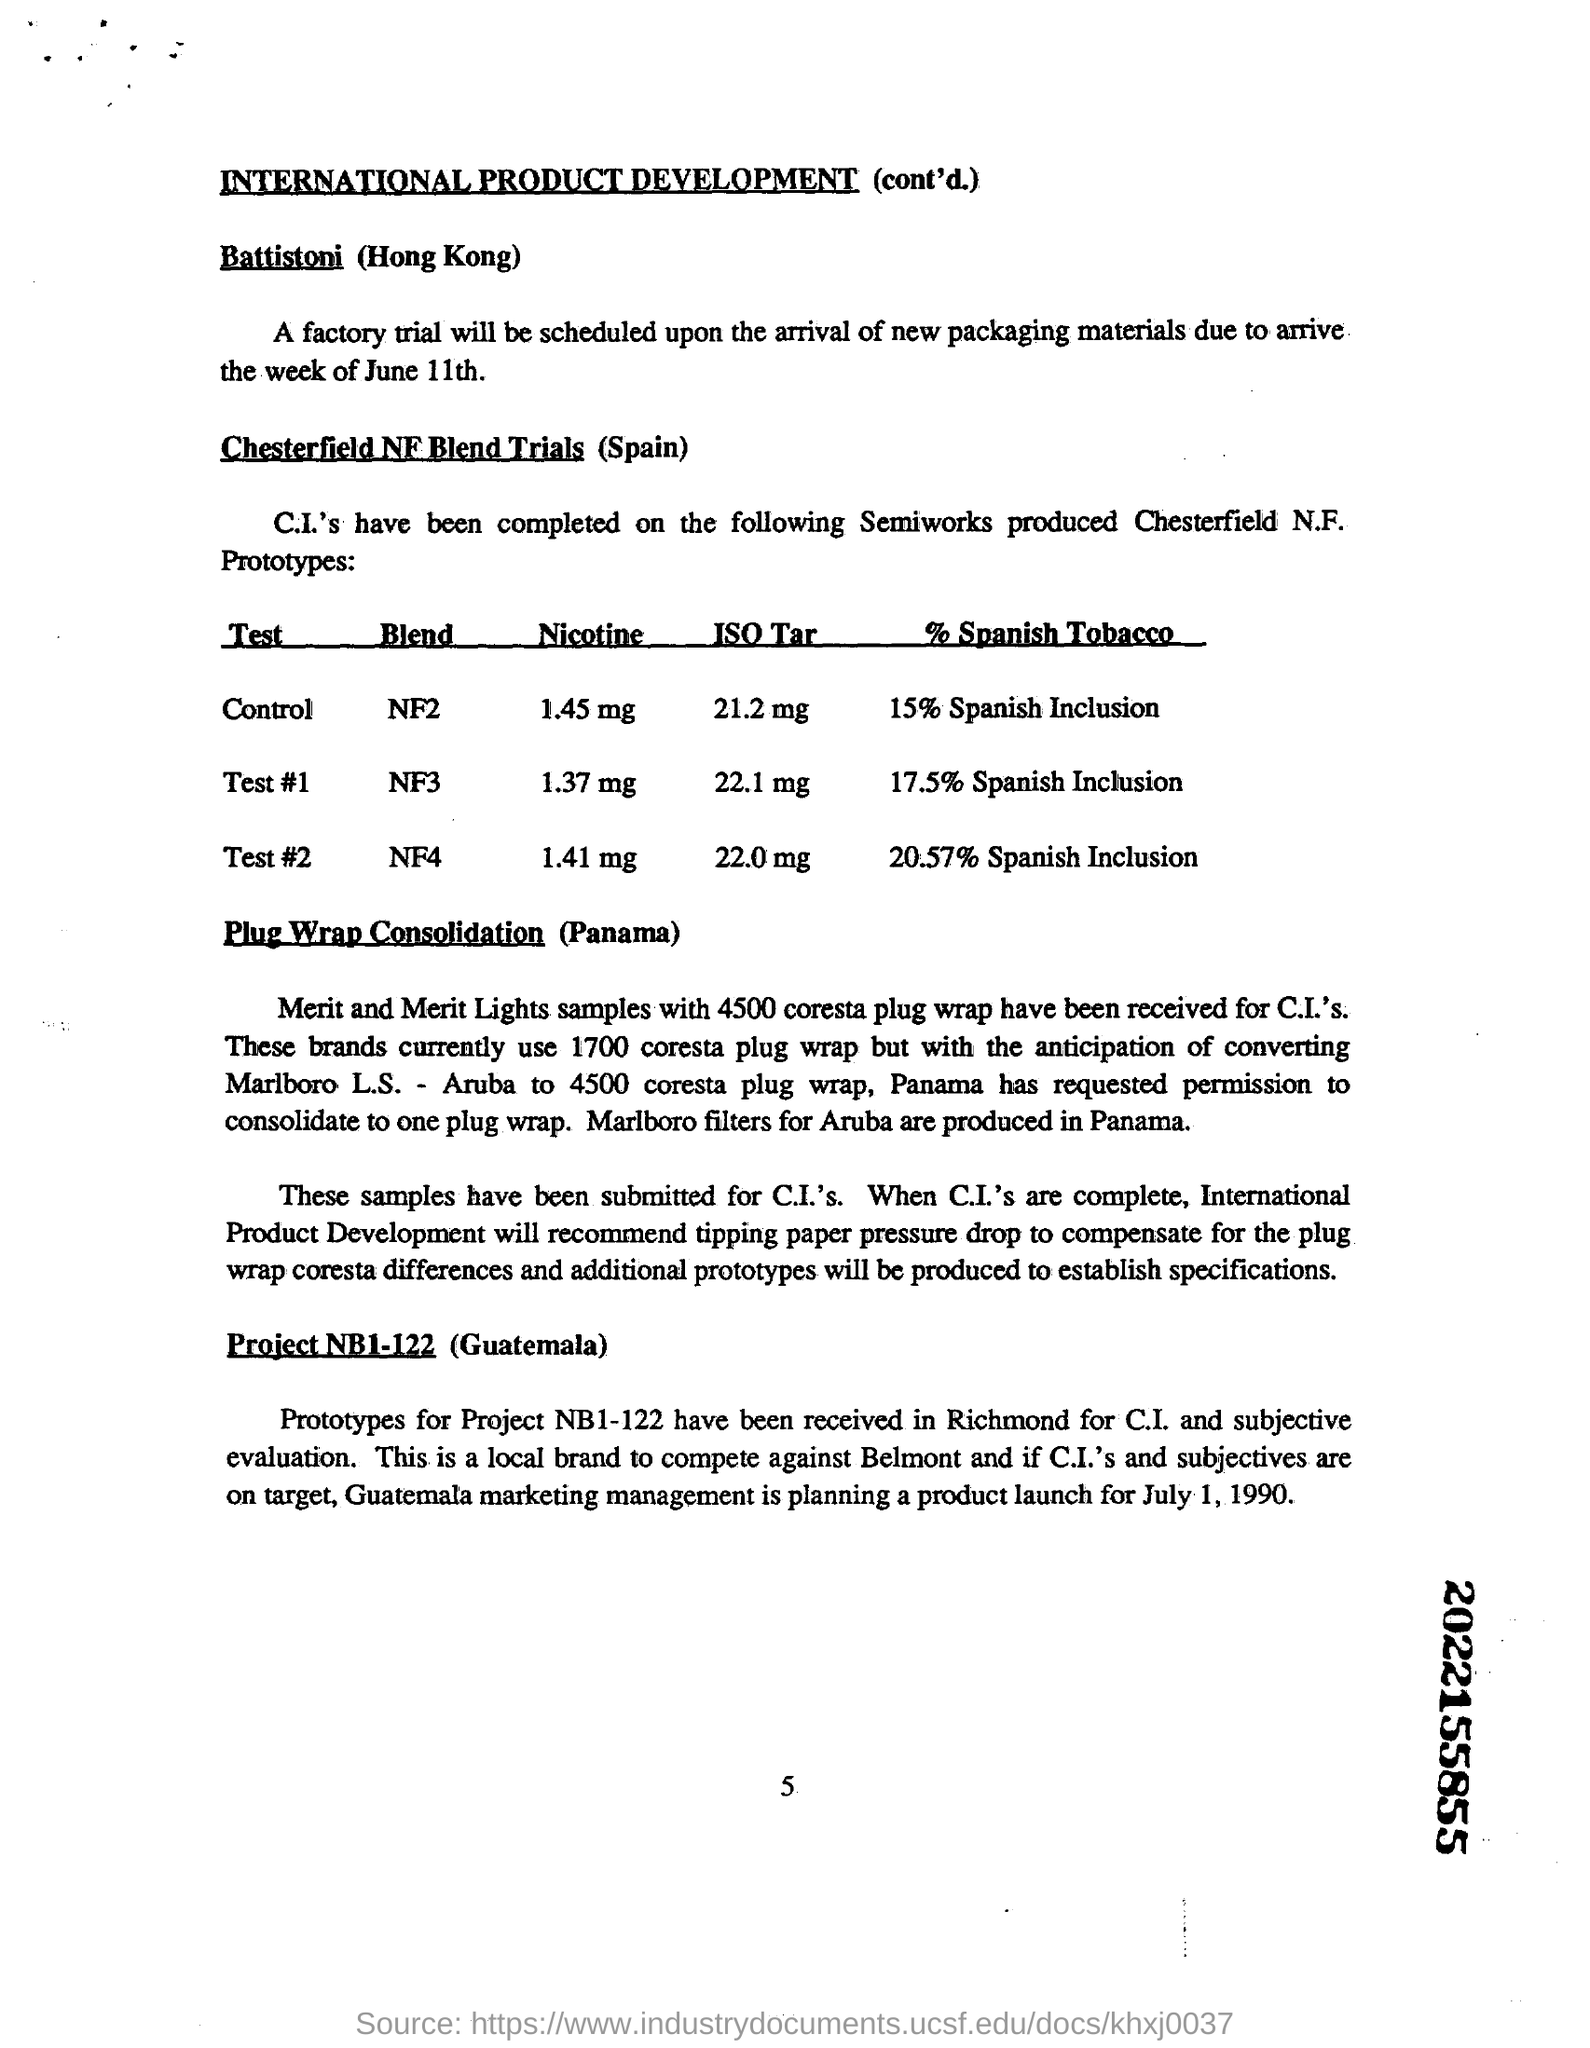How many % of Spanish Tobacco is used in Test # 1
Give a very brief answer. 17.5. When was the product launch planned by 'Guatemala' marketing management?
Offer a terse response. July 1, 1990. What is the first sub-heading in the document?
Provide a succinct answer. Battistoni. 